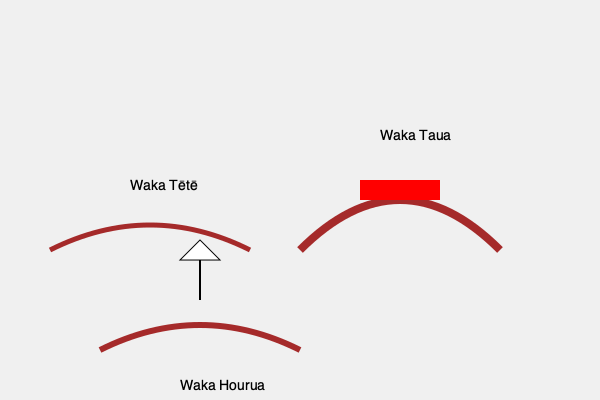Analyze the three types of Māori waka depicted in the image. Which of these was primarily used for long-distance ocean voyages and exploration, and what specific design feature enabled this function? To answer this question, we need to examine each type of waka and its characteristics:

1. Waka Tētē:
   - Smallest of the three
   - Simple, open design
   - Likely used for coastal fishing and short-distance travel

2. Waka Taua:
   - Larger and more robust
   - Decorated with red patterns
   - Primarily used as a war canoe for battles and ceremonies

3. Waka Hourua:
   - Medium-sized
   - Features a mast and sail
   - Double-hulled design (not clearly visible in the image, but implied by the name)

The waka primarily used for long-distance ocean voyages and exploration is the Waka Hourua. Its design features that enabled this function are:

a) The presence of a mast and sail, which allowed it to harness wind power for propulsion over long distances.
b) The double-hulled design (implied by the name "Hourua," which means double-hulled), which provided greater stability and carrying capacity for extended voyages.

These features made the Waka Hourua ideal for long-distance travel, exploration, and migration across the Pacific Ocean. The sail allowed for efficient travel, while the double-hull design provided stability in rough ocean conditions and space for provisions needed for extended journeys.
Answer: Waka Hourua; sail and double-hull design 